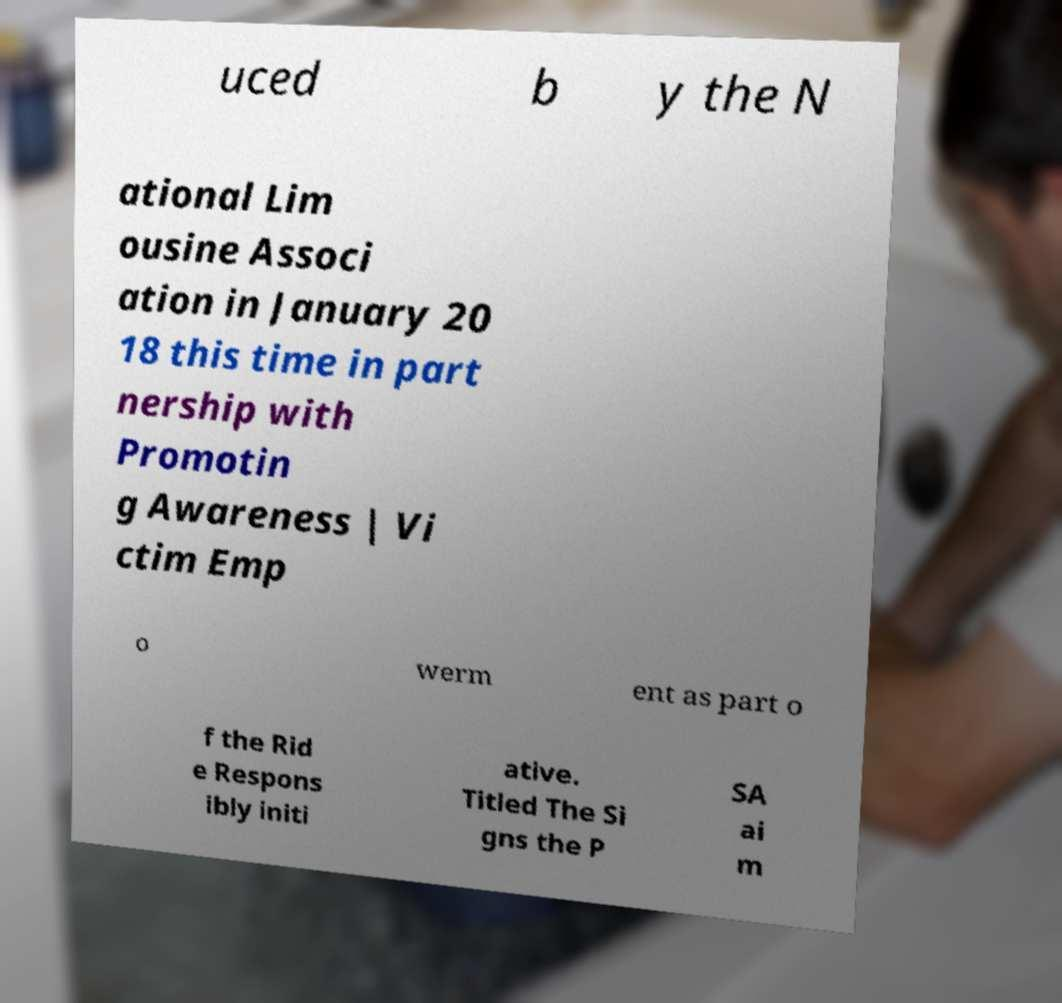There's text embedded in this image that I need extracted. Can you transcribe it verbatim? uced b y the N ational Lim ousine Associ ation in January 20 18 this time in part nership with Promotin g Awareness | Vi ctim Emp o werm ent as part o f the Rid e Respons ibly initi ative. Titled The Si gns the P SA ai m 